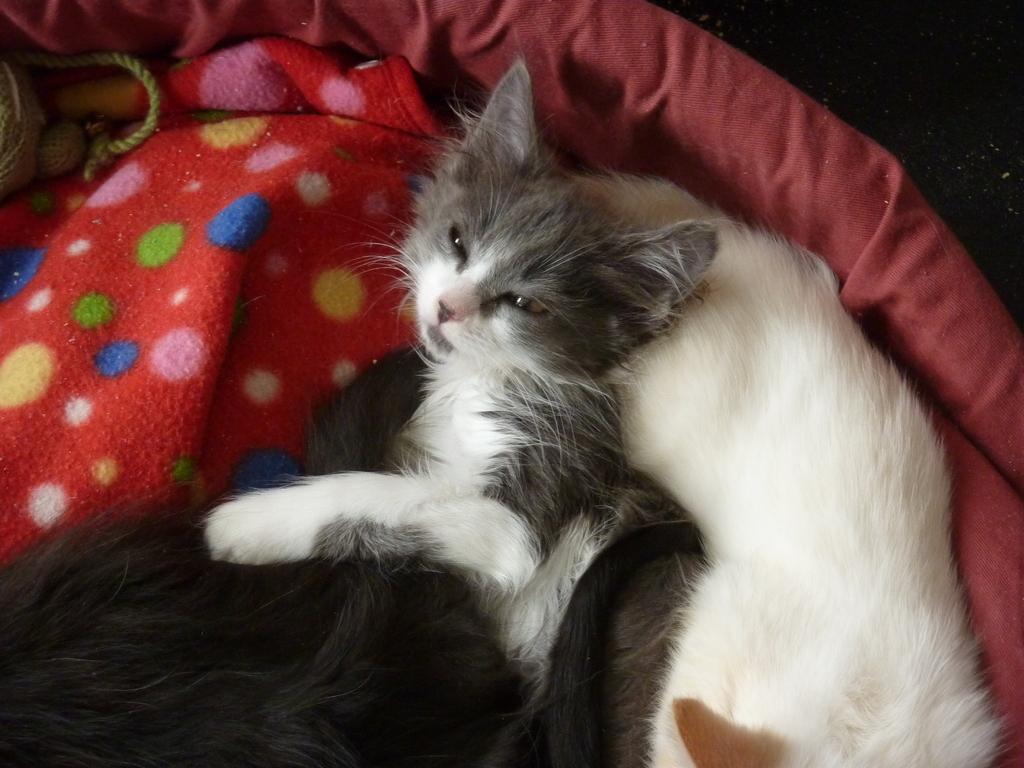Can you describe this image briefly? In this picture I can see there is a cat, lying on the bed, it has gray and white fur, there is another cat lying on the bed, it has black fur. There is a rope on the left side. 